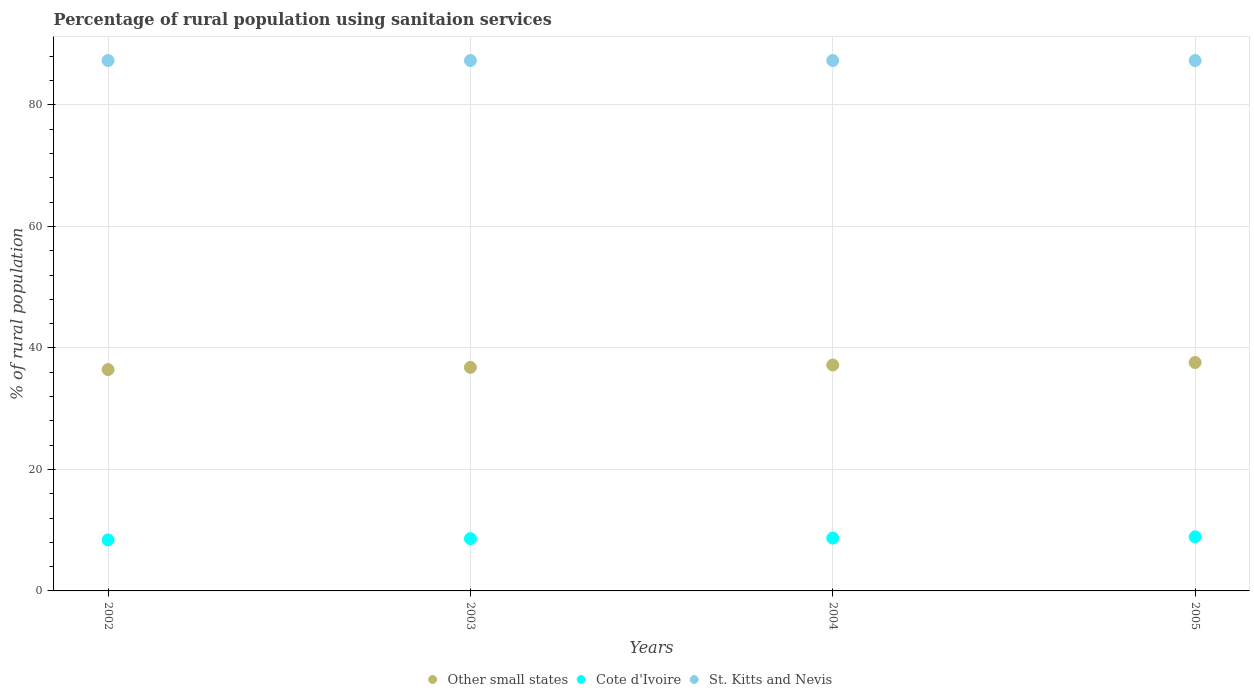How many different coloured dotlines are there?
Offer a terse response. 3. What is the percentage of rural population using sanitaion services in Other small states in 2002?
Keep it short and to the point. 36.44. Across all years, what is the minimum percentage of rural population using sanitaion services in Other small states?
Make the answer very short. 36.44. What is the total percentage of rural population using sanitaion services in Cote d'Ivoire in the graph?
Provide a succinct answer. 34.6. What is the difference between the percentage of rural population using sanitaion services in Other small states in 2002 and that in 2003?
Ensure brevity in your answer.  -0.36. What is the difference between the percentage of rural population using sanitaion services in Cote d'Ivoire in 2002 and the percentage of rural population using sanitaion services in St. Kitts and Nevis in 2003?
Your response must be concise. -78.9. What is the average percentage of rural population using sanitaion services in St. Kitts and Nevis per year?
Give a very brief answer. 87.3. In the year 2003, what is the difference between the percentage of rural population using sanitaion services in Cote d'Ivoire and percentage of rural population using sanitaion services in Other small states?
Your answer should be very brief. -28.19. What is the ratio of the percentage of rural population using sanitaion services in Other small states in 2002 to that in 2004?
Offer a terse response. 0.98. What is the difference between the highest and the second highest percentage of rural population using sanitaion services in Other small states?
Provide a short and direct response. 0.41. What is the difference between the highest and the lowest percentage of rural population using sanitaion services in Other small states?
Keep it short and to the point. 1.16. Is it the case that in every year, the sum of the percentage of rural population using sanitaion services in St. Kitts and Nevis and percentage of rural population using sanitaion services in Cote d'Ivoire  is greater than the percentage of rural population using sanitaion services in Other small states?
Offer a very short reply. Yes. Does the percentage of rural population using sanitaion services in Cote d'Ivoire monotonically increase over the years?
Your answer should be very brief. Yes. How many dotlines are there?
Your answer should be compact. 3. How many years are there in the graph?
Offer a terse response. 4. Does the graph contain any zero values?
Make the answer very short. No. Where does the legend appear in the graph?
Make the answer very short. Bottom center. What is the title of the graph?
Your response must be concise. Percentage of rural population using sanitaion services. What is the label or title of the X-axis?
Make the answer very short. Years. What is the label or title of the Y-axis?
Your answer should be compact. % of rural population. What is the % of rural population of Other small states in 2002?
Keep it short and to the point. 36.44. What is the % of rural population of St. Kitts and Nevis in 2002?
Your answer should be compact. 87.3. What is the % of rural population in Other small states in 2003?
Ensure brevity in your answer.  36.79. What is the % of rural population in St. Kitts and Nevis in 2003?
Provide a succinct answer. 87.3. What is the % of rural population of Other small states in 2004?
Offer a very short reply. 37.19. What is the % of rural population of St. Kitts and Nevis in 2004?
Your answer should be very brief. 87.3. What is the % of rural population in Other small states in 2005?
Your response must be concise. 37.6. What is the % of rural population in St. Kitts and Nevis in 2005?
Offer a terse response. 87.3. Across all years, what is the maximum % of rural population in Other small states?
Offer a terse response. 37.6. Across all years, what is the maximum % of rural population of St. Kitts and Nevis?
Your answer should be compact. 87.3. Across all years, what is the minimum % of rural population in Other small states?
Provide a short and direct response. 36.44. Across all years, what is the minimum % of rural population in Cote d'Ivoire?
Ensure brevity in your answer.  8.4. Across all years, what is the minimum % of rural population in St. Kitts and Nevis?
Offer a very short reply. 87.3. What is the total % of rural population of Other small states in the graph?
Your answer should be very brief. 148.01. What is the total % of rural population of Cote d'Ivoire in the graph?
Give a very brief answer. 34.6. What is the total % of rural population in St. Kitts and Nevis in the graph?
Offer a terse response. 349.2. What is the difference between the % of rural population in Other small states in 2002 and that in 2003?
Provide a short and direct response. -0.36. What is the difference between the % of rural population of St. Kitts and Nevis in 2002 and that in 2003?
Provide a short and direct response. 0. What is the difference between the % of rural population of Other small states in 2002 and that in 2004?
Your answer should be compact. -0.75. What is the difference between the % of rural population of St. Kitts and Nevis in 2002 and that in 2004?
Offer a very short reply. 0. What is the difference between the % of rural population of Other small states in 2002 and that in 2005?
Your answer should be very brief. -1.16. What is the difference between the % of rural population of Other small states in 2003 and that in 2004?
Your response must be concise. -0.39. What is the difference between the % of rural population of St. Kitts and Nevis in 2003 and that in 2004?
Give a very brief answer. 0. What is the difference between the % of rural population in Other small states in 2003 and that in 2005?
Your answer should be compact. -0.8. What is the difference between the % of rural population in Other small states in 2004 and that in 2005?
Provide a short and direct response. -0.41. What is the difference between the % of rural population of St. Kitts and Nevis in 2004 and that in 2005?
Your answer should be very brief. 0. What is the difference between the % of rural population in Other small states in 2002 and the % of rural population in Cote d'Ivoire in 2003?
Offer a very short reply. 27.84. What is the difference between the % of rural population of Other small states in 2002 and the % of rural population of St. Kitts and Nevis in 2003?
Provide a short and direct response. -50.86. What is the difference between the % of rural population of Cote d'Ivoire in 2002 and the % of rural population of St. Kitts and Nevis in 2003?
Provide a succinct answer. -78.9. What is the difference between the % of rural population of Other small states in 2002 and the % of rural population of Cote d'Ivoire in 2004?
Ensure brevity in your answer.  27.74. What is the difference between the % of rural population in Other small states in 2002 and the % of rural population in St. Kitts and Nevis in 2004?
Ensure brevity in your answer.  -50.86. What is the difference between the % of rural population of Cote d'Ivoire in 2002 and the % of rural population of St. Kitts and Nevis in 2004?
Ensure brevity in your answer.  -78.9. What is the difference between the % of rural population in Other small states in 2002 and the % of rural population in Cote d'Ivoire in 2005?
Keep it short and to the point. 27.54. What is the difference between the % of rural population in Other small states in 2002 and the % of rural population in St. Kitts and Nevis in 2005?
Your answer should be compact. -50.86. What is the difference between the % of rural population of Cote d'Ivoire in 2002 and the % of rural population of St. Kitts and Nevis in 2005?
Offer a terse response. -78.9. What is the difference between the % of rural population of Other small states in 2003 and the % of rural population of Cote d'Ivoire in 2004?
Your response must be concise. 28.09. What is the difference between the % of rural population in Other small states in 2003 and the % of rural population in St. Kitts and Nevis in 2004?
Ensure brevity in your answer.  -50.51. What is the difference between the % of rural population in Cote d'Ivoire in 2003 and the % of rural population in St. Kitts and Nevis in 2004?
Give a very brief answer. -78.7. What is the difference between the % of rural population in Other small states in 2003 and the % of rural population in Cote d'Ivoire in 2005?
Your answer should be very brief. 27.89. What is the difference between the % of rural population of Other small states in 2003 and the % of rural population of St. Kitts and Nevis in 2005?
Provide a short and direct response. -50.51. What is the difference between the % of rural population of Cote d'Ivoire in 2003 and the % of rural population of St. Kitts and Nevis in 2005?
Your answer should be very brief. -78.7. What is the difference between the % of rural population of Other small states in 2004 and the % of rural population of Cote d'Ivoire in 2005?
Your answer should be very brief. 28.29. What is the difference between the % of rural population in Other small states in 2004 and the % of rural population in St. Kitts and Nevis in 2005?
Keep it short and to the point. -50.11. What is the difference between the % of rural population in Cote d'Ivoire in 2004 and the % of rural population in St. Kitts and Nevis in 2005?
Offer a very short reply. -78.6. What is the average % of rural population of Other small states per year?
Your response must be concise. 37. What is the average % of rural population in Cote d'Ivoire per year?
Give a very brief answer. 8.65. What is the average % of rural population of St. Kitts and Nevis per year?
Offer a very short reply. 87.3. In the year 2002, what is the difference between the % of rural population in Other small states and % of rural population in Cote d'Ivoire?
Keep it short and to the point. 28.04. In the year 2002, what is the difference between the % of rural population in Other small states and % of rural population in St. Kitts and Nevis?
Offer a very short reply. -50.86. In the year 2002, what is the difference between the % of rural population of Cote d'Ivoire and % of rural population of St. Kitts and Nevis?
Keep it short and to the point. -78.9. In the year 2003, what is the difference between the % of rural population in Other small states and % of rural population in Cote d'Ivoire?
Offer a terse response. 28.19. In the year 2003, what is the difference between the % of rural population in Other small states and % of rural population in St. Kitts and Nevis?
Ensure brevity in your answer.  -50.51. In the year 2003, what is the difference between the % of rural population of Cote d'Ivoire and % of rural population of St. Kitts and Nevis?
Your answer should be compact. -78.7. In the year 2004, what is the difference between the % of rural population in Other small states and % of rural population in Cote d'Ivoire?
Make the answer very short. 28.49. In the year 2004, what is the difference between the % of rural population in Other small states and % of rural population in St. Kitts and Nevis?
Your answer should be compact. -50.11. In the year 2004, what is the difference between the % of rural population in Cote d'Ivoire and % of rural population in St. Kitts and Nevis?
Your answer should be very brief. -78.6. In the year 2005, what is the difference between the % of rural population of Other small states and % of rural population of Cote d'Ivoire?
Provide a succinct answer. 28.7. In the year 2005, what is the difference between the % of rural population in Other small states and % of rural population in St. Kitts and Nevis?
Make the answer very short. -49.7. In the year 2005, what is the difference between the % of rural population of Cote d'Ivoire and % of rural population of St. Kitts and Nevis?
Provide a succinct answer. -78.4. What is the ratio of the % of rural population in Other small states in 2002 to that in 2003?
Your answer should be compact. 0.99. What is the ratio of the % of rural population in Cote d'Ivoire in 2002 to that in 2003?
Offer a very short reply. 0.98. What is the ratio of the % of rural population in St. Kitts and Nevis in 2002 to that in 2003?
Your response must be concise. 1. What is the ratio of the % of rural population in Other small states in 2002 to that in 2004?
Provide a succinct answer. 0.98. What is the ratio of the % of rural population of Cote d'Ivoire in 2002 to that in 2004?
Your answer should be compact. 0.97. What is the ratio of the % of rural population of St. Kitts and Nevis in 2002 to that in 2004?
Offer a very short reply. 1. What is the ratio of the % of rural population of Other small states in 2002 to that in 2005?
Your answer should be compact. 0.97. What is the ratio of the % of rural population of Cote d'Ivoire in 2002 to that in 2005?
Your answer should be compact. 0.94. What is the ratio of the % of rural population in Other small states in 2003 to that in 2004?
Offer a terse response. 0.99. What is the ratio of the % of rural population in Other small states in 2003 to that in 2005?
Offer a very short reply. 0.98. What is the ratio of the % of rural population in Cote d'Ivoire in 2003 to that in 2005?
Provide a short and direct response. 0.97. What is the ratio of the % of rural population in Other small states in 2004 to that in 2005?
Your response must be concise. 0.99. What is the ratio of the % of rural population in Cote d'Ivoire in 2004 to that in 2005?
Give a very brief answer. 0.98. What is the ratio of the % of rural population of St. Kitts and Nevis in 2004 to that in 2005?
Give a very brief answer. 1. What is the difference between the highest and the second highest % of rural population in Other small states?
Your answer should be compact. 0.41. What is the difference between the highest and the second highest % of rural population in Cote d'Ivoire?
Give a very brief answer. 0.2. What is the difference between the highest and the lowest % of rural population in Other small states?
Ensure brevity in your answer.  1.16. What is the difference between the highest and the lowest % of rural population in St. Kitts and Nevis?
Give a very brief answer. 0. 